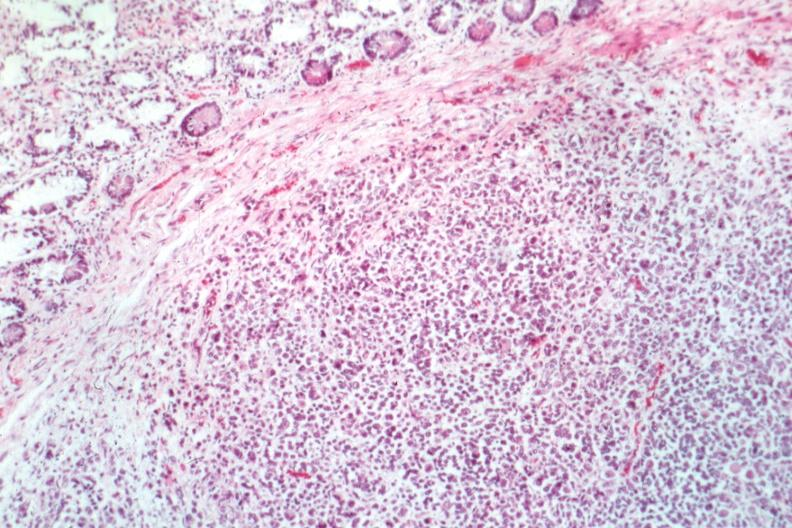s the excellent uterus present?
Answer the question using a single word or phrase. No 